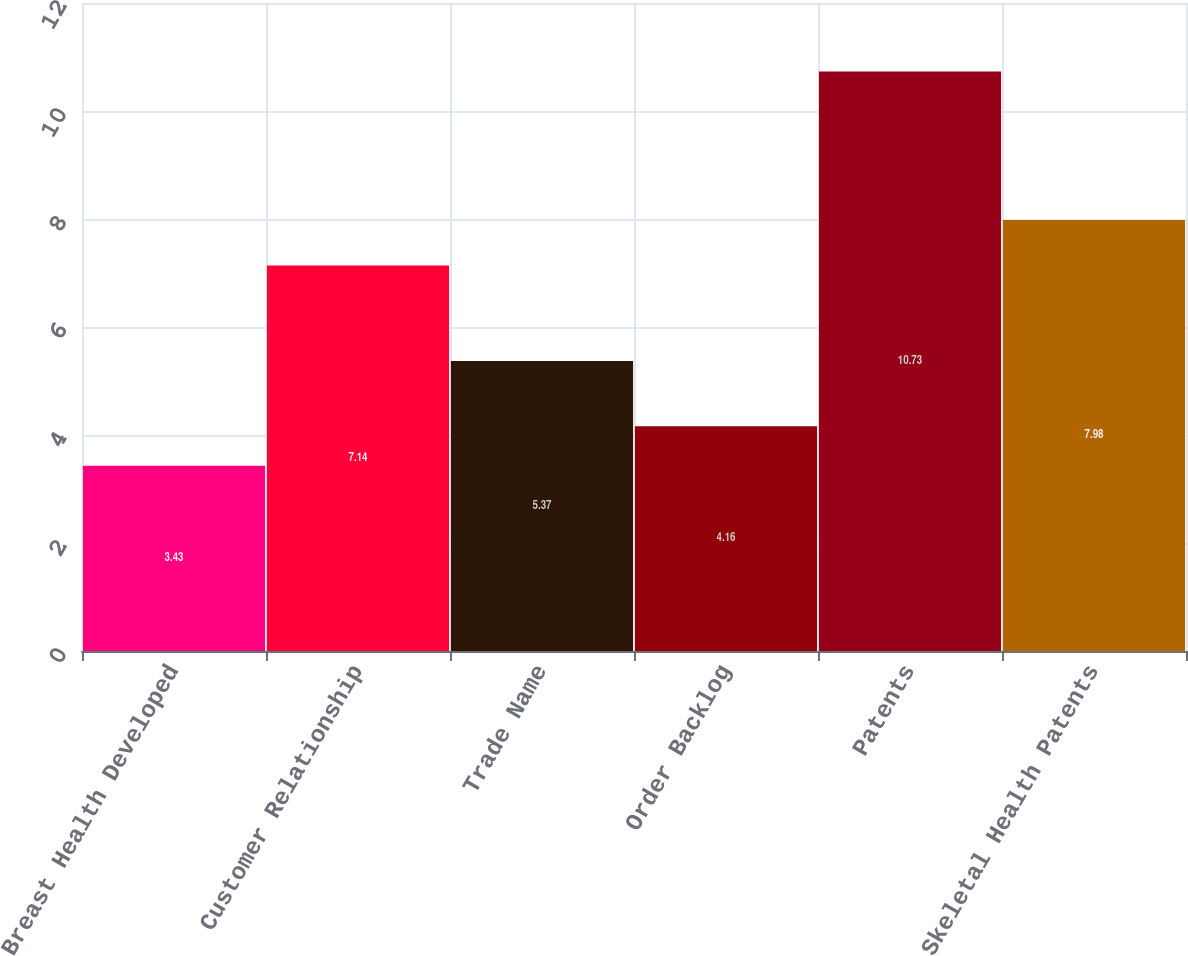<chart> <loc_0><loc_0><loc_500><loc_500><bar_chart><fcel>Breast Health Developed<fcel>Customer Relationship<fcel>Trade Name<fcel>Order Backlog<fcel>Patents<fcel>Skeletal Health Patents<nl><fcel>3.43<fcel>7.14<fcel>5.37<fcel>4.16<fcel>10.73<fcel>7.98<nl></chart> 